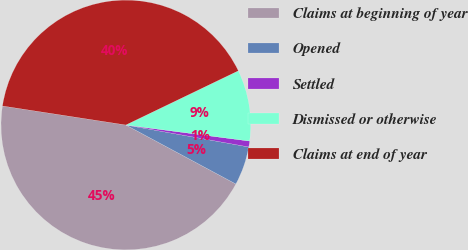Convert chart. <chart><loc_0><loc_0><loc_500><loc_500><pie_chart><fcel>Claims at beginning of year<fcel>Opened<fcel>Settled<fcel>Dismissed or otherwise<fcel>Claims at end of year<nl><fcel>44.6%<fcel>5.02%<fcel>0.76%<fcel>9.2%<fcel>40.43%<nl></chart> 